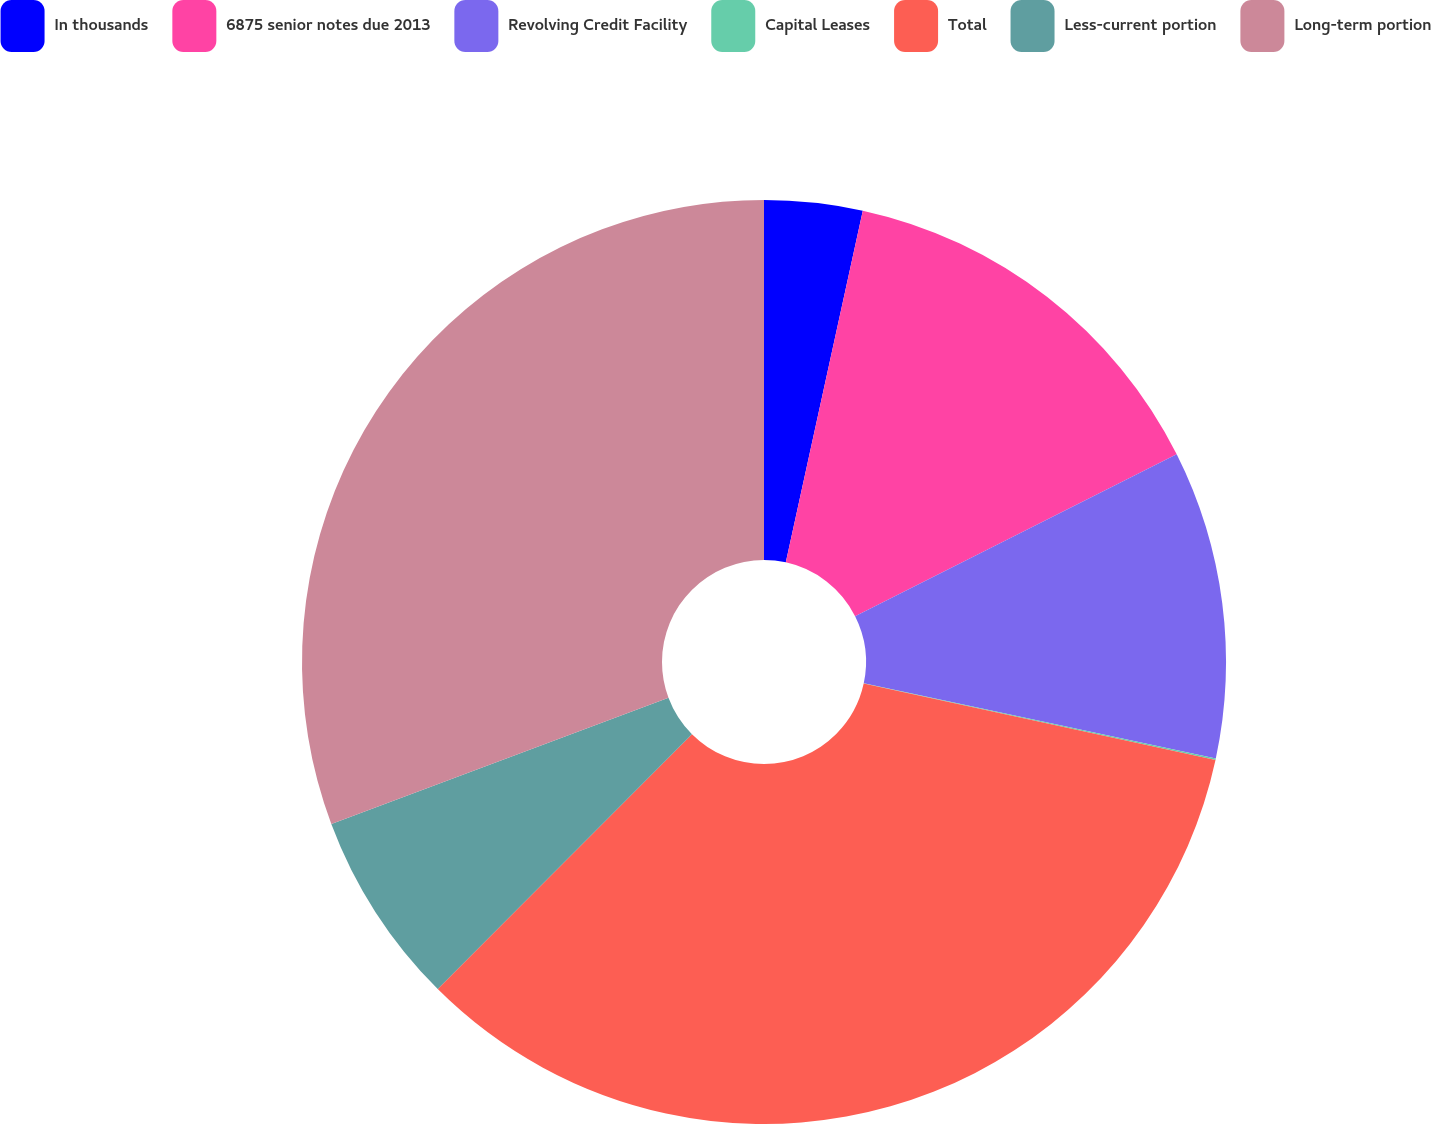Convert chart. <chart><loc_0><loc_0><loc_500><loc_500><pie_chart><fcel>In thousands<fcel>6875 senior notes due 2013<fcel>Revolving Credit Facility<fcel>Capital Leases<fcel>Total<fcel>Less-current portion<fcel>Long-term portion<nl><fcel>3.43%<fcel>14.15%<fcel>10.77%<fcel>0.05%<fcel>34.08%<fcel>6.82%<fcel>30.7%<nl></chart> 